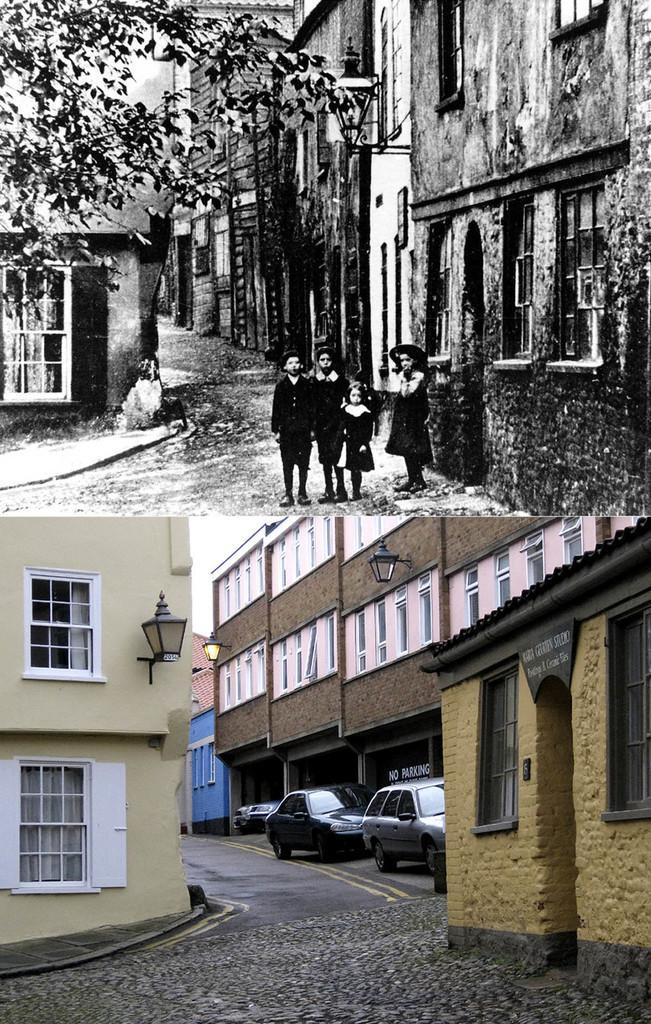How would you summarize this image in a sentence or two? This image is a collage of two images. At the bottom of the image there are a few buildings with walls, windows and doors and two cars are parked on the road. The image which is on the top is a black and white image. In this image there are a few buildings and four kids are standing on the road and there is a tree. 